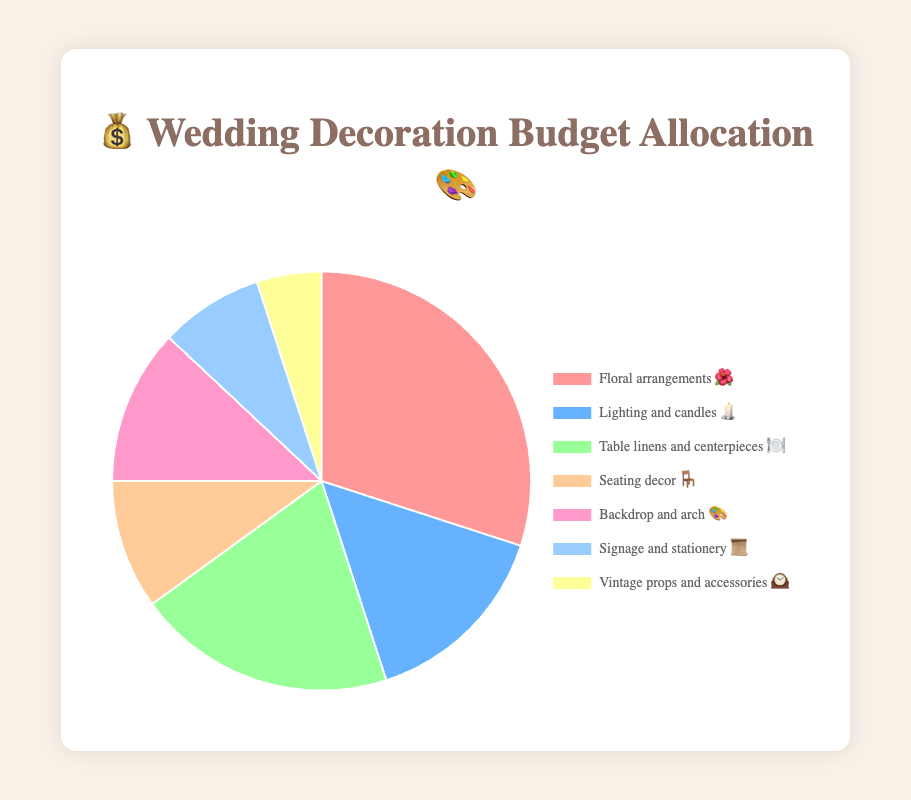What category has the highest percentage allocation? The category with the highest percentage allocation has the largest segment in the pie chart. In this case, "Floral arrangements 🌺" has the highest allocation.
Answer: Floral arrangements 🌺 Which category has the smallest budget allocation? The segment with the smallest percentage is the one with the smallest area on the chart. "Vintage props and accessories 🕰️" has the smallest allocation.
Answer: Vintage props and accessories 🕰️ What's the total percentage allocated to both "Lighting and candles 🕯️" and "Table linens and centerpieces 🍽️"? Add the percentages of "Lighting and candles 🕯️" (15%) and "Table linens and centerpieces 🍽️" (20%). The sum is 15% + 20% = 35%.
Answer: 35% How much more is allocated to "Floral arrangements 🌺" compared to "Backdrop and arch 🎨"? Subtract the percentage for "Backdrop and arch 🎨" (12%) from "Floral arrangements 🌺" (30%). The difference is 30% - 12% = 18%.
Answer: 18% Are there any categories with a budget allocation less than 10%? Check each segment to see which ones have a percentage below 10%. "Signage and stationery 📜" (8%) and "Vintage props and accessories 🕰️" (5%) are both less than 10%.
Answer: Yes Which categories together constitute exactly half of the budget? Combine percentages until they add up to 50%. "Floral arrangements 🌺" (30%) and "Lighting and candles 🕯️" (15%) together total 45%, adding "Vintage props and accessories 🕰️" (5%) gives exactly 50%.
Answer: Floral arrangements 🌺, Lighting and candles 🕯️, Vintage props and accessories 🕰️ Which categories have a budget allocation between 10% and 20%? Check each segment's percentage to see if it falls within this range. "Lighting and candles 🕯️" (15%), "Table linens and centerpieces 🍽️" (20%), "Seating decor 🪑" (10%), and "Backdrop and arch 🎨" (12%) are within this range.
Answer: Lighting and candles 🕯️, Table linens and centerpieces 🍽️, Seating decor 🪑, Backdrop and arch 🎨 